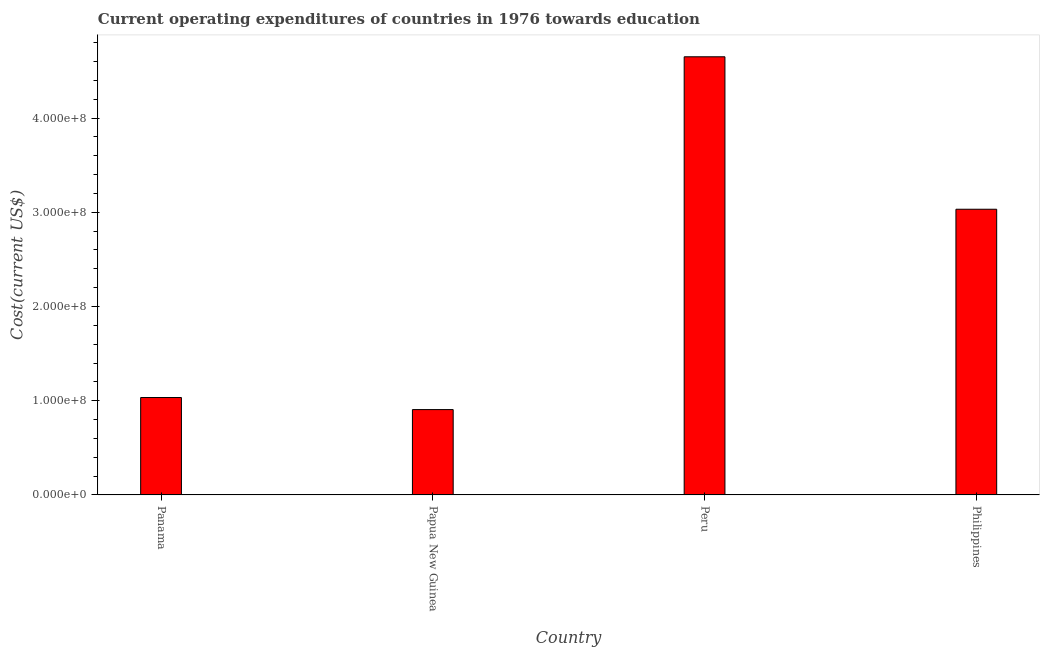What is the title of the graph?
Provide a succinct answer. Current operating expenditures of countries in 1976 towards education. What is the label or title of the X-axis?
Offer a terse response. Country. What is the label or title of the Y-axis?
Your response must be concise. Cost(current US$). What is the education expenditure in Philippines?
Give a very brief answer. 3.03e+08. Across all countries, what is the maximum education expenditure?
Make the answer very short. 4.65e+08. Across all countries, what is the minimum education expenditure?
Your response must be concise. 9.06e+07. In which country was the education expenditure minimum?
Ensure brevity in your answer.  Papua New Guinea. What is the sum of the education expenditure?
Your answer should be compact. 9.62e+08. What is the difference between the education expenditure in Peru and Philippines?
Provide a short and direct response. 1.62e+08. What is the average education expenditure per country?
Give a very brief answer. 2.41e+08. What is the median education expenditure?
Make the answer very short. 2.03e+08. What is the ratio of the education expenditure in Panama to that in Philippines?
Keep it short and to the point. 0.34. What is the difference between the highest and the second highest education expenditure?
Offer a terse response. 1.62e+08. What is the difference between the highest and the lowest education expenditure?
Provide a succinct answer. 3.74e+08. Are all the bars in the graph horizontal?
Offer a terse response. No. How many countries are there in the graph?
Offer a terse response. 4. What is the difference between two consecutive major ticks on the Y-axis?
Ensure brevity in your answer.  1.00e+08. What is the Cost(current US$) in Panama?
Give a very brief answer. 1.03e+08. What is the Cost(current US$) of Papua New Guinea?
Provide a short and direct response. 9.06e+07. What is the Cost(current US$) of Peru?
Provide a short and direct response. 4.65e+08. What is the Cost(current US$) of Philippines?
Make the answer very short. 3.03e+08. What is the difference between the Cost(current US$) in Panama and Papua New Guinea?
Your response must be concise. 1.28e+07. What is the difference between the Cost(current US$) in Panama and Peru?
Give a very brief answer. -3.62e+08. What is the difference between the Cost(current US$) in Panama and Philippines?
Make the answer very short. -2.00e+08. What is the difference between the Cost(current US$) in Papua New Guinea and Peru?
Your answer should be very brief. -3.74e+08. What is the difference between the Cost(current US$) in Papua New Guinea and Philippines?
Your response must be concise. -2.13e+08. What is the difference between the Cost(current US$) in Peru and Philippines?
Provide a short and direct response. 1.62e+08. What is the ratio of the Cost(current US$) in Panama to that in Papua New Guinea?
Make the answer very short. 1.14. What is the ratio of the Cost(current US$) in Panama to that in Peru?
Provide a short and direct response. 0.22. What is the ratio of the Cost(current US$) in Panama to that in Philippines?
Provide a succinct answer. 0.34. What is the ratio of the Cost(current US$) in Papua New Guinea to that in Peru?
Your answer should be very brief. 0.2. What is the ratio of the Cost(current US$) in Papua New Guinea to that in Philippines?
Offer a very short reply. 0.3. What is the ratio of the Cost(current US$) in Peru to that in Philippines?
Offer a terse response. 1.53. 